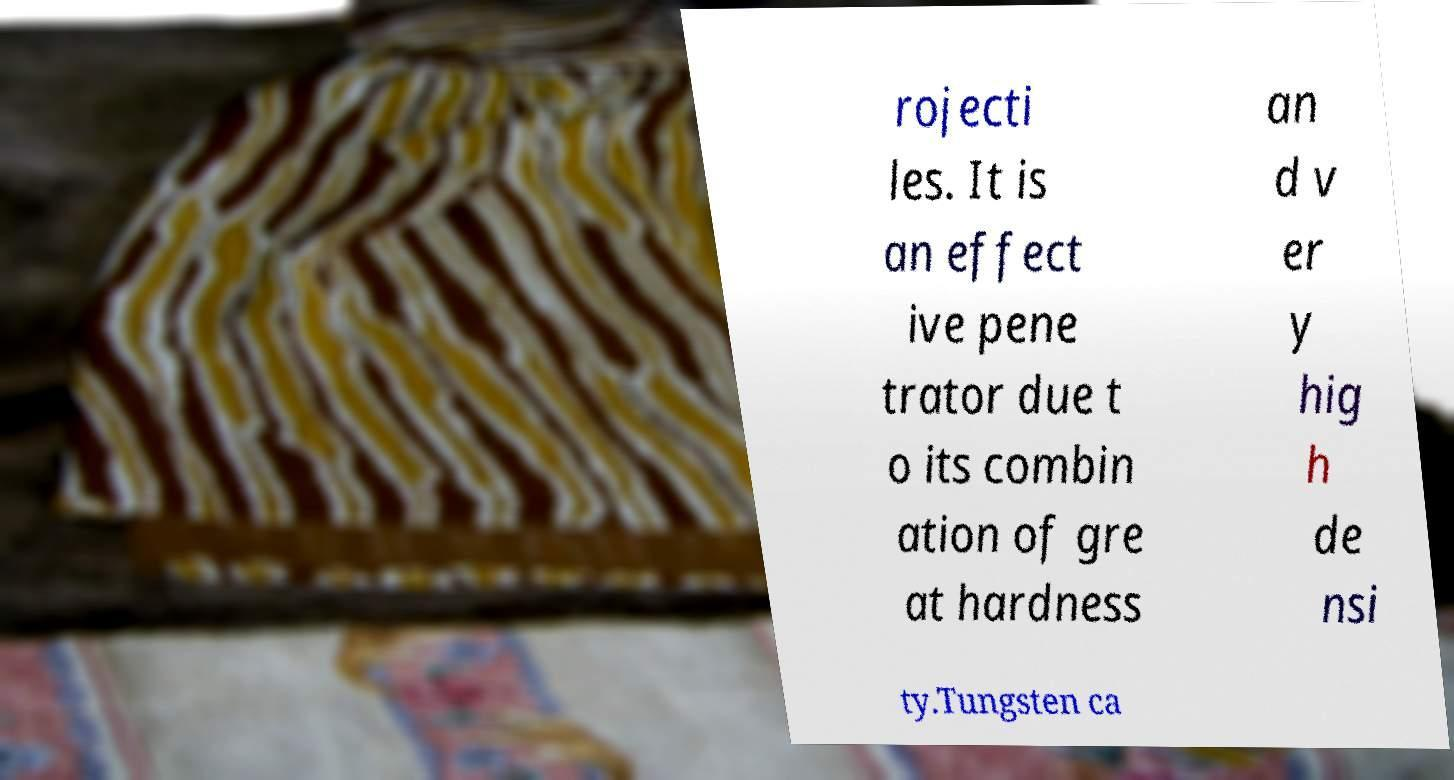I need the written content from this picture converted into text. Can you do that? rojecti les. It is an effect ive pene trator due t o its combin ation of gre at hardness an d v er y hig h de nsi ty.Tungsten ca 